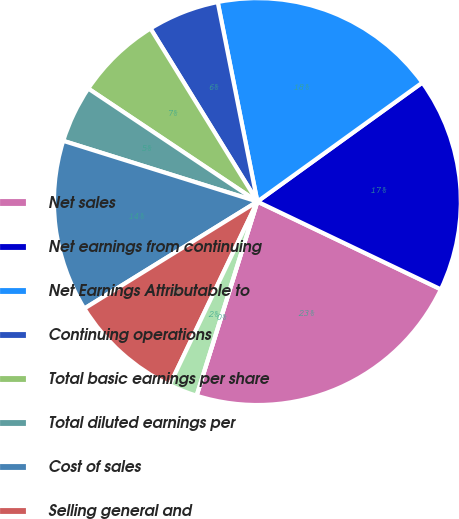Convert chart to OTSL. <chart><loc_0><loc_0><loc_500><loc_500><pie_chart><fcel>Net sales<fcel>Net earnings from continuing<fcel>Net Earnings Attributable to<fcel>Continuing operations<fcel>Total basic earnings per share<fcel>Total diluted earnings per<fcel>Cost of sales<fcel>Selling general and<fcel>Other net<fcel>Restructuring charges and<nl><fcel>22.73%<fcel>17.05%<fcel>18.18%<fcel>5.68%<fcel>6.82%<fcel>4.55%<fcel>13.64%<fcel>9.09%<fcel>2.27%<fcel>0.0%<nl></chart> 